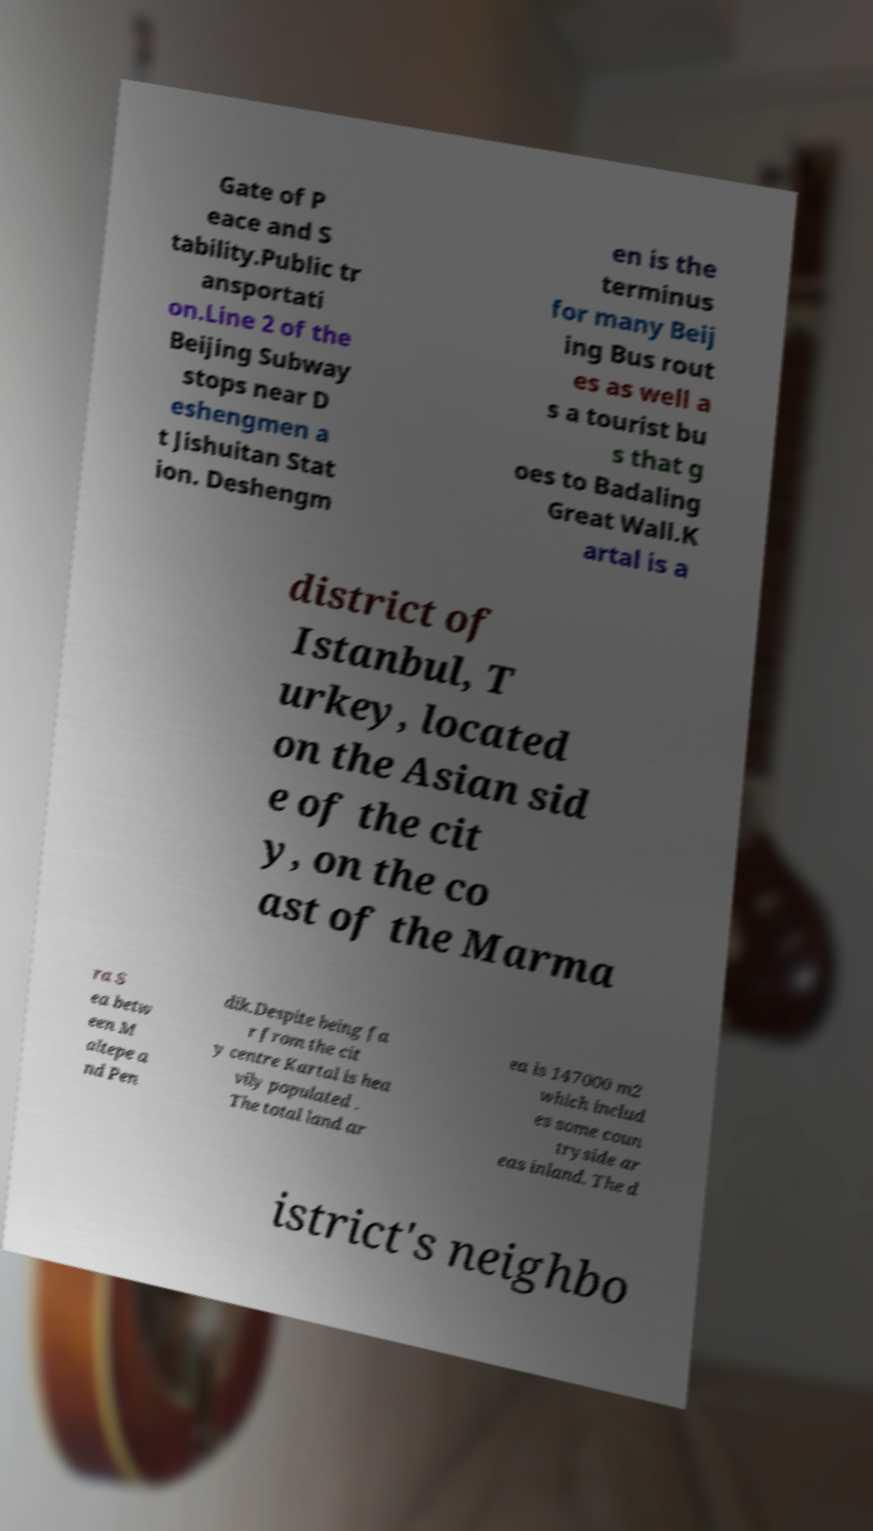Please identify and transcribe the text found in this image. Gate of P eace and S tability.Public tr ansportati on.Line 2 of the Beijing Subway stops near D eshengmen a t Jishuitan Stat ion. Deshengm en is the terminus for many Beij ing Bus rout es as well a s a tourist bu s that g oes to Badaling Great Wall.K artal is a district of Istanbul, T urkey, located on the Asian sid e of the cit y, on the co ast of the Marma ra S ea betw een M altepe a nd Pen dik.Despite being fa r from the cit y centre Kartal is hea vily populated . The total land ar ea is 147000 m2 which includ es some coun tryside ar eas inland. The d istrict's neighbo 